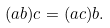<formula> <loc_0><loc_0><loc_500><loc_500>( a b ) c = ( a c ) b .</formula> 